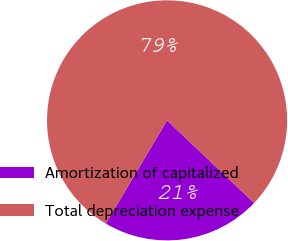<chart> <loc_0><loc_0><loc_500><loc_500><pie_chart><fcel>Amortization of capitalized<fcel>Total depreciation expense<nl><fcel>21.44%<fcel>78.56%<nl></chart> 